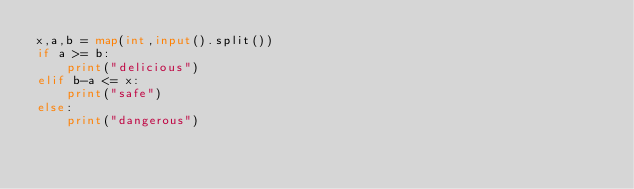Convert code to text. <code><loc_0><loc_0><loc_500><loc_500><_Python_>x,a,b = map(int,input().split())
if a >= b:
    print("delicious")
elif b-a <= x:
    print("safe")
else:
    print("dangerous")
</code> 